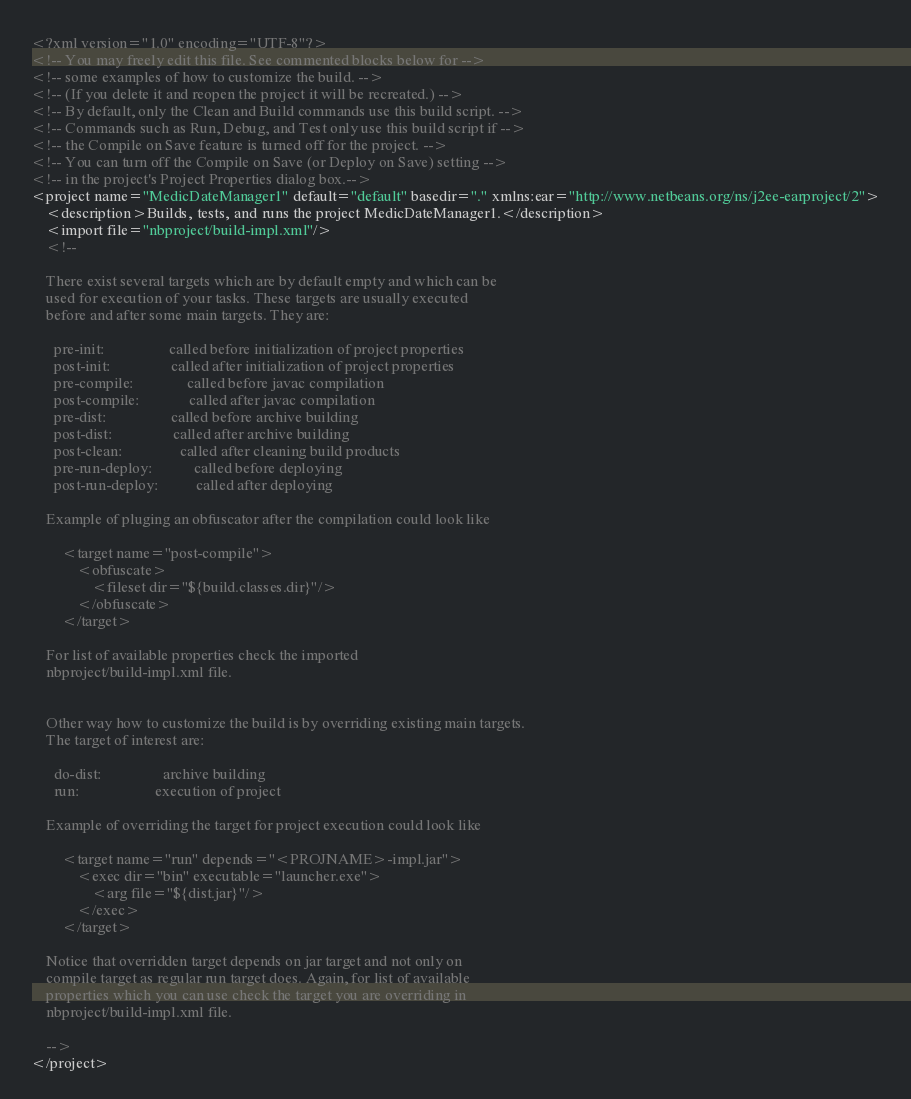<code> <loc_0><loc_0><loc_500><loc_500><_XML_><?xml version="1.0" encoding="UTF-8"?>
<!-- You may freely edit this file. See commented blocks below for -->
<!-- some examples of how to customize the build. -->
<!-- (If you delete it and reopen the project it will be recreated.) -->
<!-- By default, only the Clean and Build commands use this build script. -->
<!-- Commands such as Run, Debug, and Test only use this build script if -->
<!-- the Compile on Save feature is turned off for the project. -->
<!-- You can turn off the Compile on Save (or Deploy on Save) setting -->
<!-- in the project's Project Properties dialog box.-->
<project name="MedicDateManager1" default="default" basedir="." xmlns:ear="http://www.netbeans.org/ns/j2ee-earproject/2">
    <description>Builds, tests, and runs the project MedicDateManager1.</description>
    <import file="nbproject/build-impl.xml"/>
    <!--

    There exist several targets which are by default empty and which can be 
    used for execution of your tasks. These targets are usually executed 
    before and after some main targets. They are: 

      pre-init:                 called before initialization of project properties 
      post-init:                called after initialization of project properties 
      pre-compile:              called before javac compilation 
      post-compile:             called after javac compilation 
      pre-dist:                 called before archive building 
      post-dist:                called after archive building 
      post-clean:               called after cleaning build products 
      pre-run-deploy:           called before deploying
      post-run-deploy:          called after deploying

    Example of pluging an obfuscator after the compilation could look like 

        <target name="post-compile">
            <obfuscate>
                <fileset dir="${build.classes.dir}"/>
            </obfuscate>
        </target>

    For list of available properties check the imported 
    nbproject/build-impl.xml file. 


    Other way how to customize the build is by overriding existing main targets.
    The target of interest are: 

      do-dist:                archive building
      run:                    execution of project 

    Example of overriding the target for project execution could look like 

        <target name="run" depends="<PROJNAME>-impl.jar">
            <exec dir="bin" executable="launcher.exe">
                <arg file="${dist.jar}"/>
            </exec>
        </target>

    Notice that overridden target depends on jar target and not only on 
    compile target as regular run target does. Again, for list of available 
    properties which you can use check the target you are overriding in 
    nbproject/build-impl.xml file. 

    -->
</project>
</code> 